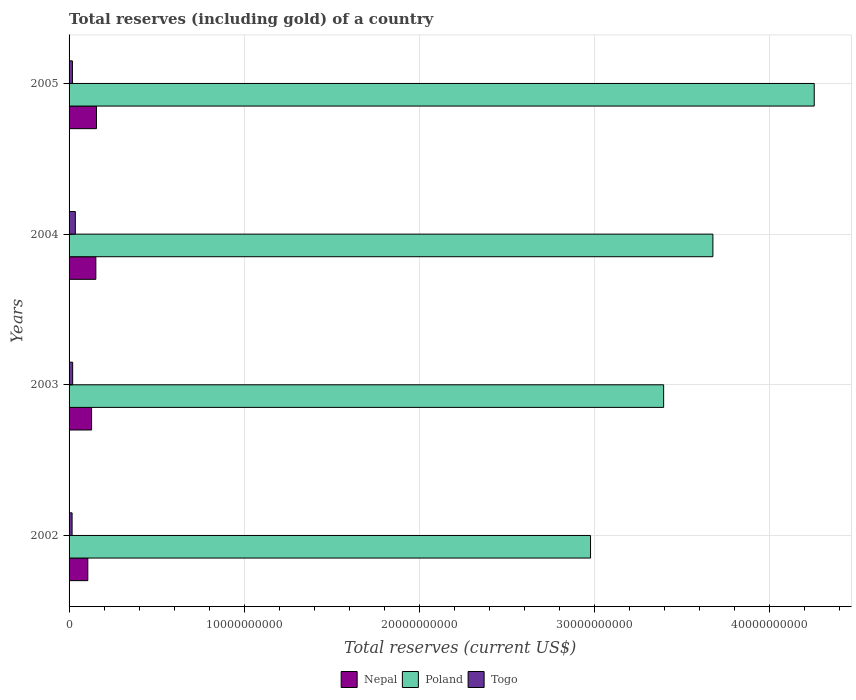How many groups of bars are there?
Keep it short and to the point. 4. Are the number of bars per tick equal to the number of legend labels?
Your answer should be compact. Yes. Are the number of bars on each tick of the Y-axis equal?
Make the answer very short. Yes. How many bars are there on the 4th tick from the top?
Your answer should be compact. 3. What is the label of the 4th group of bars from the top?
Offer a very short reply. 2002. What is the total reserves (including gold) in Poland in 2005?
Make the answer very short. 4.26e+1. Across all years, what is the maximum total reserves (including gold) in Nepal?
Ensure brevity in your answer.  1.57e+09. Across all years, what is the minimum total reserves (including gold) in Nepal?
Make the answer very short. 1.07e+09. In which year was the total reserves (including gold) in Poland maximum?
Your answer should be compact. 2005. In which year was the total reserves (including gold) in Togo minimum?
Your response must be concise. 2002. What is the total total reserves (including gold) in Togo in the graph?
Provide a succinct answer. 9.27e+08. What is the difference between the total reserves (including gold) in Togo in 2002 and that in 2003?
Your answer should be very brief. -3.25e+07. What is the difference between the total reserves (including gold) in Togo in 2005 and the total reserves (including gold) in Poland in 2003?
Provide a succinct answer. -3.38e+1. What is the average total reserves (including gold) in Poland per year?
Offer a terse response. 3.58e+1. In the year 2002, what is the difference between the total reserves (including gold) in Togo and total reserves (including gold) in Nepal?
Offer a very short reply. -8.98e+08. What is the ratio of the total reserves (including gold) in Nepal in 2002 to that in 2004?
Offer a very short reply. 0.7. Is the total reserves (including gold) in Nepal in 2003 less than that in 2004?
Ensure brevity in your answer.  Yes. Is the difference between the total reserves (including gold) in Togo in 2003 and 2005 greater than the difference between the total reserves (including gold) in Nepal in 2003 and 2005?
Your answer should be very brief. Yes. What is the difference between the highest and the second highest total reserves (including gold) in Nepal?
Keep it short and to the point. 3.61e+07. What is the difference between the highest and the lowest total reserves (including gold) in Poland?
Your response must be concise. 1.28e+1. What does the 2nd bar from the top in 2004 represents?
Keep it short and to the point. Poland. Is it the case that in every year, the sum of the total reserves (including gold) in Togo and total reserves (including gold) in Nepal is greater than the total reserves (including gold) in Poland?
Your response must be concise. No. How many bars are there?
Offer a very short reply. 12. Are all the bars in the graph horizontal?
Your answer should be very brief. Yes. How many years are there in the graph?
Offer a terse response. 4. Does the graph contain grids?
Ensure brevity in your answer.  Yes. How are the legend labels stacked?
Offer a terse response. Horizontal. What is the title of the graph?
Offer a terse response. Total reserves (including gold) of a country. What is the label or title of the X-axis?
Give a very brief answer. Total reserves (current US$). What is the label or title of the Y-axis?
Offer a very short reply. Years. What is the Total reserves (current US$) of Nepal in 2002?
Your answer should be compact. 1.07e+09. What is the Total reserves (current US$) of Poland in 2002?
Make the answer very short. 2.98e+1. What is the Total reserves (current US$) in Togo in 2002?
Keep it short and to the point. 1.72e+08. What is the Total reserves (current US$) in Nepal in 2003?
Provide a short and direct response. 1.29e+09. What is the Total reserves (current US$) in Poland in 2003?
Your response must be concise. 3.40e+1. What is the Total reserves (current US$) of Togo in 2003?
Your response must be concise. 2.05e+08. What is the Total reserves (current US$) in Nepal in 2004?
Ensure brevity in your answer.  1.53e+09. What is the Total reserves (current US$) in Poland in 2004?
Provide a succinct answer. 3.68e+1. What is the Total reserves (current US$) in Togo in 2004?
Your response must be concise. 3.58e+08. What is the Total reserves (current US$) in Nepal in 2005?
Provide a succinct answer. 1.57e+09. What is the Total reserves (current US$) of Poland in 2005?
Provide a short and direct response. 4.26e+1. What is the Total reserves (current US$) of Togo in 2005?
Keep it short and to the point. 1.92e+08. Across all years, what is the maximum Total reserves (current US$) in Nepal?
Offer a terse response. 1.57e+09. Across all years, what is the maximum Total reserves (current US$) of Poland?
Offer a terse response. 4.26e+1. Across all years, what is the maximum Total reserves (current US$) in Togo?
Give a very brief answer. 3.58e+08. Across all years, what is the minimum Total reserves (current US$) of Nepal?
Give a very brief answer. 1.07e+09. Across all years, what is the minimum Total reserves (current US$) of Poland?
Provide a short and direct response. 2.98e+1. Across all years, what is the minimum Total reserves (current US$) in Togo?
Make the answer very short. 1.72e+08. What is the total Total reserves (current US$) of Nepal in the graph?
Keep it short and to the point. 5.45e+09. What is the total Total reserves (current US$) of Poland in the graph?
Offer a terse response. 1.43e+11. What is the total Total reserves (current US$) of Togo in the graph?
Your answer should be compact. 9.27e+08. What is the difference between the Total reserves (current US$) in Nepal in 2002 and that in 2003?
Make the answer very short. -2.16e+08. What is the difference between the Total reserves (current US$) of Poland in 2002 and that in 2003?
Make the answer very short. -4.18e+09. What is the difference between the Total reserves (current US$) in Togo in 2002 and that in 2003?
Your response must be concise. -3.25e+07. What is the difference between the Total reserves (current US$) of Nepal in 2002 and that in 2004?
Ensure brevity in your answer.  -4.59e+08. What is the difference between the Total reserves (current US$) in Poland in 2002 and that in 2004?
Keep it short and to the point. -6.99e+09. What is the difference between the Total reserves (current US$) in Togo in 2002 and that in 2004?
Offer a terse response. -1.85e+08. What is the difference between the Total reserves (current US$) in Nepal in 2002 and that in 2005?
Your answer should be compact. -4.95e+08. What is the difference between the Total reserves (current US$) of Poland in 2002 and that in 2005?
Offer a very short reply. -1.28e+1. What is the difference between the Total reserves (current US$) in Togo in 2002 and that in 2005?
Offer a very short reply. -1.91e+07. What is the difference between the Total reserves (current US$) of Nepal in 2003 and that in 2004?
Give a very brief answer. -2.43e+08. What is the difference between the Total reserves (current US$) of Poland in 2003 and that in 2004?
Provide a short and direct response. -2.81e+09. What is the difference between the Total reserves (current US$) of Togo in 2003 and that in 2004?
Make the answer very short. -1.53e+08. What is the difference between the Total reserves (current US$) of Nepal in 2003 and that in 2005?
Your answer should be compact. -2.79e+08. What is the difference between the Total reserves (current US$) of Poland in 2003 and that in 2005?
Your response must be concise. -8.60e+09. What is the difference between the Total reserves (current US$) of Togo in 2003 and that in 2005?
Offer a terse response. 1.33e+07. What is the difference between the Total reserves (current US$) of Nepal in 2004 and that in 2005?
Make the answer very short. -3.61e+07. What is the difference between the Total reserves (current US$) in Poland in 2004 and that in 2005?
Your answer should be very brief. -5.79e+09. What is the difference between the Total reserves (current US$) in Togo in 2004 and that in 2005?
Give a very brief answer. 1.66e+08. What is the difference between the Total reserves (current US$) of Nepal in 2002 and the Total reserves (current US$) of Poland in 2003?
Offer a terse response. -3.29e+1. What is the difference between the Total reserves (current US$) in Nepal in 2002 and the Total reserves (current US$) in Togo in 2003?
Make the answer very short. 8.65e+08. What is the difference between the Total reserves (current US$) in Poland in 2002 and the Total reserves (current US$) in Togo in 2003?
Offer a very short reply. 2.96e+1. What is the difference between the Total reserves (current US$) of Nepal in 2002 and the Total reserves (current US$) of Poland in 2004?
Ensure brevity in your answer.  -3.57e+1. What is the difference between the Total reserves (current US$) of Nepal in 2002 and the Total reserves (current US$) of Togo in 2004?
Your answer should be compact. 7.12e+08. What is the difference between the Total reserves (current US$) in Poland in 2002 and the Total reserves (current US$) in Togo in 2004?
Provide a succinct answer. 2.94e+1. What is the difference between the Total reserves (current US$) of Nepal in 2002 and the Total reserves (current US$) of Poland in 2005?
Offer a terse response. -4.15e+1. What is the difference between the Total reserves (current US$) in Nepal in 2002 and the Total reserves (current US$) in Togo in 2005?
Provide a short and direct response. 8.78e+08. What is the difference between the Total reserves (current US$) in Poland in 2002 and the Total reserves (current US$) in Togo in 2005?
Ensure brevity in your answer.  2.96e+1. What is the difference between the Total reserves (current US$) of Nepal in 2003 and the Total reserves (current US$) of Poland in 2004?
Your answer should be very brief. -3.55e+1. What is the difference between the Total reserves (current US$) of Nepal in 2003 and the Total reserves (current US$) of Togo in 2004?
Offer a very short reply. 9.29e+08. What is the difference between the Total reserves (current US$) in Poland in 2003 and the Total reserves (current US$) in Togo in 2004?
Keep it short and to the point. 3.36e+1. What is the difference between the Total reserves (current US$) of Nepal in 2003 and the Total reserves (current US$) of Poland in 2005?
Ensure brevity in your answer.  -4.13e+1. What is the difference between the Total reserves (current US$) in Nepal in 2003 and the Total reserves (current US$) in Togo in 2005?
Offer a terse response. 1.09e+09. What is the difference between the Total reserves (current US$) in Poland in 2003 and the Total reserves (current US$) in Togo in 2005?
Keep it short and to the point. 3.38e+1. What is the difference between the Total reserves (current US$) of Nepal in 2004 and the Total reserves (current US$) of Poland in 2005?
Provide a succinct answer. -4.10e+1. What is the difference between the Total reserves (current US$) of Nepal in 2004 and the Total reserves (current US$) of Togo in 2005?
Provide a short and direct response. 1.34e+09. What is the difference between the Total reserves (current US$) in Poland in 2004 and the Total reserves (current US$) in Togo in 2005?
Offer a terse response. 3.66e+1. What is the average Total reserves (current US$) of Nepal per year?
Your response must be concise. 1.36e+09. What is the average Total reserves (current US$) of Poland per year?
Keep it short and to the point. 3.58e+1. What is the average Total reserves (current US$) of Togo per year?
Provide a short and direct response. 2.32e+08. In the year 2002, what is the difference between the Total reserves (current US$) in Nepal and Total reserves (current US$) in Poland?
Offer a terse response. -2.87e+1. In the year 2002, what is the difference between the Total reserves (current US$) in Nepal and Total reserves (current US$) in Togo?
Your answer should be compact. 8.98e+08. In the year 2002, what is the difference between the Total reserves (current US$) of Poland and Total reserves (current US$) of Togo?
Make the answer very short. 2.96e+1. In the year 2003, what is the difference between the Total reserves (current US$) of Nepal and Total reserves (current US$) of Poland?
Ensure brevity in your answer.  -3.27e+1. In the year 2003, what is the difference between the Total reserves (current US$) of Nepal and Total reserves (current US$) of Togo?
Offer a terse response. 1.08e+09. In the year 2003, what is the difference between the Total reserves (current US$) in Poland and Total reserves (current US$) in Togo?
Give a very brief answer. 3.38e+1. In the year 2004, what is the difference between the Total reserves (current US$) in Nepal and Total reserves (current US$) in Poland?
Provide a short and direct response. -3.52e+1. In the year 2004, what is the difference between the Total reserves (current US$) in Nepal and Total reserves (current US$) in Togo?
Your answer should be very brief. 1.17e+09. In the year 2004, what is the difference between the Total reserves (current US$) in Poland and Total reserves (current US$) in Togo?
Your answer should be compact. 3.64e+1. In the year 2005, what is the difference between the Total reserves (current US$) in Nepal and Total reserves (current US$) in Poland?
Your response must be concise. -4.10e+1. In the year 2005, what is the difference between the Total reserves (current US$) of Nepal and Total reserves (current US$) of Togo?
Ensure brevity in your answer.  1.37e+09. In the year 2005, what is the difference between the Total reserves (current US$) in Poland and Total reserves (current US$) in Togo?
Your response must be concise. 4.24e+1. What is the ratio of the Total reserves (current US$) of Nepal in 2002 to that in 2003?
Ensure brevity in your answer.  0.83. What is the ratio of the Total reserves (current US$) of Poland in 2002 to that in 2003?
Ensure brevity in your answer.  0.88. What is the ratio of the Total reserves (current US$) of Togo in 2002 to that in 2003?
Offer a very short reply. 0.84. What is the ratio of the Total reserves (current US$) in Nepal in 2002 to that in 2004?
Give a very brief answer. 0.7. What is the ratio of the Total reserves (current US$) in Poland in 2002 to that in 2004?
Offer a very short reply. 0.81. What is the ratio of the Total reserves (current US$) in Togo in 2002 to that in 2004?
Your answer should be very brief. 0.48. What is the ratio of the Total reserves (current US$) in Nepal in 2002 to that in 2005?
Give a very brief answer. 0.68. What is the ratio of the Total reserves (current US$) in Poland in 2002 to that in 2005?
Make the answer very short. 0.7. What is the ratio of the Total reserves (current US$) in Togo in 2002 to that in 2005?
Make the answer very short. 0.9. What is the ratio of the Total reserves (current US$) of Nepal in 2003 to that in 2004?
Your answer should be very brief. 0.84. What is the ratio of the Total reserves (current US$) of Poland in 2003 to that in 2004?
Give a very brief answer. 0.92. What is the ratio of the Total reserves (current US$) of Togo in 2003 to that in 2004?
Offer a very short reply. 0.57. What is the ratio of the Total reserves (current US$) of Nepal in 2003 to that in 2005?
Provide a short and direct response. 0.82. What is the ratio of the Total reserves (current US$) in Poland in 2003 to that in 2005?
Make the answer very short. 0.8. What is the ratio of the Total reserves (current US$) of Togo in 2003 to that in 2005?
Provide a short and direct response. 1.07. What is the ratio of the Total reserves (current US$) in Nepal in 2004 to that in 2005?
Offer a very short reply. 0.98. What is the ratio of the Total reserves (current US$) in Poland in 2004 to that in 2005?
Ensure brevity in your answer.  0.86. What is the ratio of the Total reserves (current US$) of Togo in 2004 to that in 2005?
Your answer should be compact. 1.87. What is the difference between the highest and the second highest Total reserves (current US$) of Nepal?
Keep it short and to the point. 3.61e+07. What is the difference between the highest and the second highest Total reserves (current US$) of Poland?
Offer a terse response. 5.79e+09. What is the difference between the highest and the second highest Total reserves (current US$) in Togo?
Ensure brevity in your answer.  1.53e+08. What is the difference between the highest and the lowest Total reserves (current US$) in Nepal?
Provide a short and direct response. 4.95e+08. What is the difference between the highest and the lowest Total reserves (current US$) of Poland?
Your answer should be very brief. 1.28e+1. What is the difference between the highest and the lowest Total reserves (current US$) in Togo?
Your answer should be compact. 1.85e+08. 